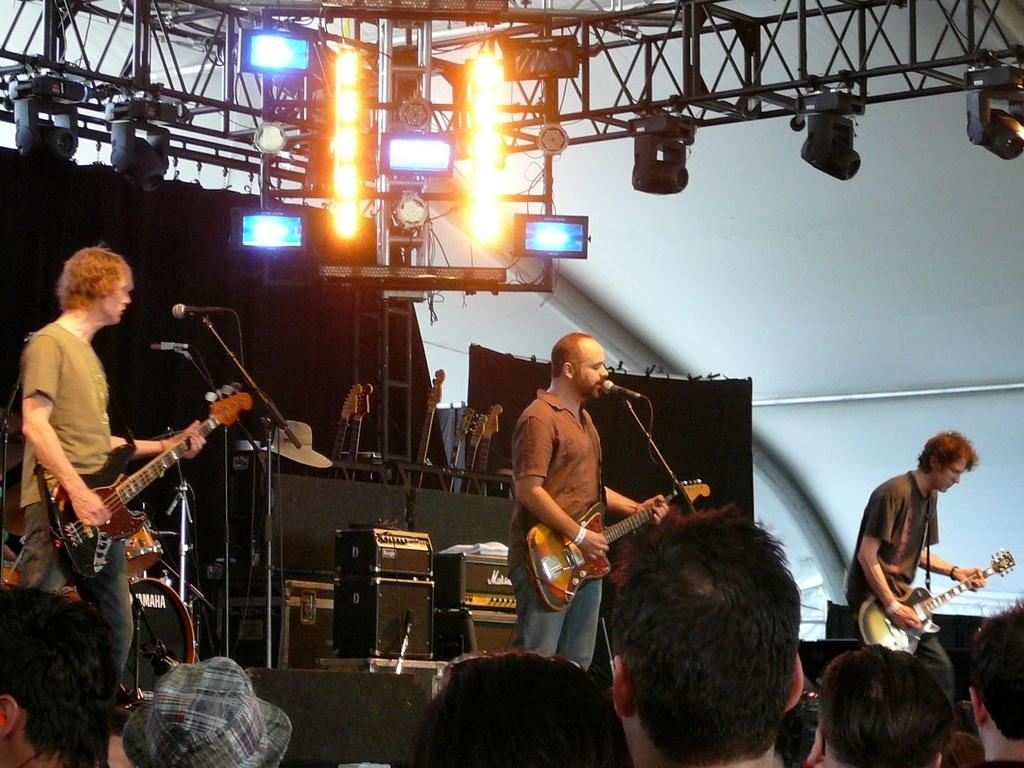What are the three men in the image doing? The three men are performing in the image. What instruments are the men playing? The men are playing guitar. How are the men communicating with the audience? The men are singing on a microphone. What is the stage-like platform called in the image? There is a dais in the image. Who is observing the performance? There is an audience watching the performance. What type of news can be seen on the bear's ink-covered paws in the image? There is no bear or ink present in the image, and therefore no news can be seen on its paws. 